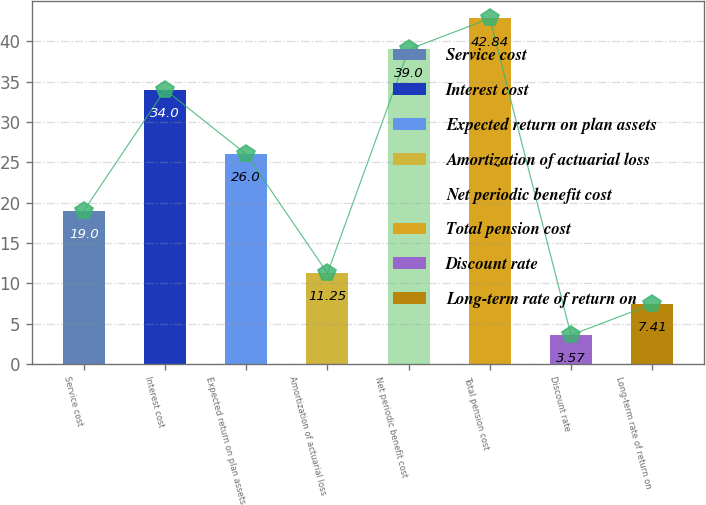Convert chart to OTSL. <chart><loc_0><loc_0><loc_500><loc_500><bar_chart><fcel>Service cost<fcel>Interest cost<fcel>Expected return on plan assets<fcel>Amortization of actuarial loss<fcel>Net periodic benefit cost<fcel>Total pension cost<fcel>Discount rate<fcel>Long-term rate of return on<nl><fcel>19<fcel>34<fcel>26<fcel>11.25<fcel>39<fcel>42.84<fcel>3.57<fcel>7.41<nl></chart> 